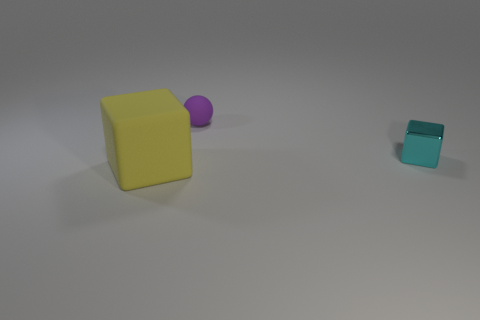Is the number of purple objects that are behind the big cube greater than the number of large brown matte cubes?
Provide a short and direct response. Yes. The metallic block that is the same size as the purple rubber sphere is what color?
Offer a very short reply. Cyan. Are there any small purple matte objects behind the cube in front of the tiny cube?
Provide a short and direct response. Yes. There is a tiny object that is behind the small block; what material is it?
Offer a very short reply. Rubber. Are the block in front of the cyan metal object and the thing that is behind the cyan block made of the same material?
Your response must be concise. Yes. Are there an equal number of small metal cubes behind the cyan metallic thing and matte things to the right of the rubber cube?
Your answer should be very brief. No. How many other purple objects are the same material as the large thing?
Your answer should be compact. 1. How big is the rubber thing that is behind the cube left of the small cyan shiny cube?
Offer a very short reply. Small. There is a thing that is right of the purple object; is its shape the same as the matte thing that is on the right side of the large yellow matte object?
Offer a terse response. No. Is the number of matte balls that are behind the cyan object the same as the number of small matte spheres?
Provide a succinct answer. Yes. 